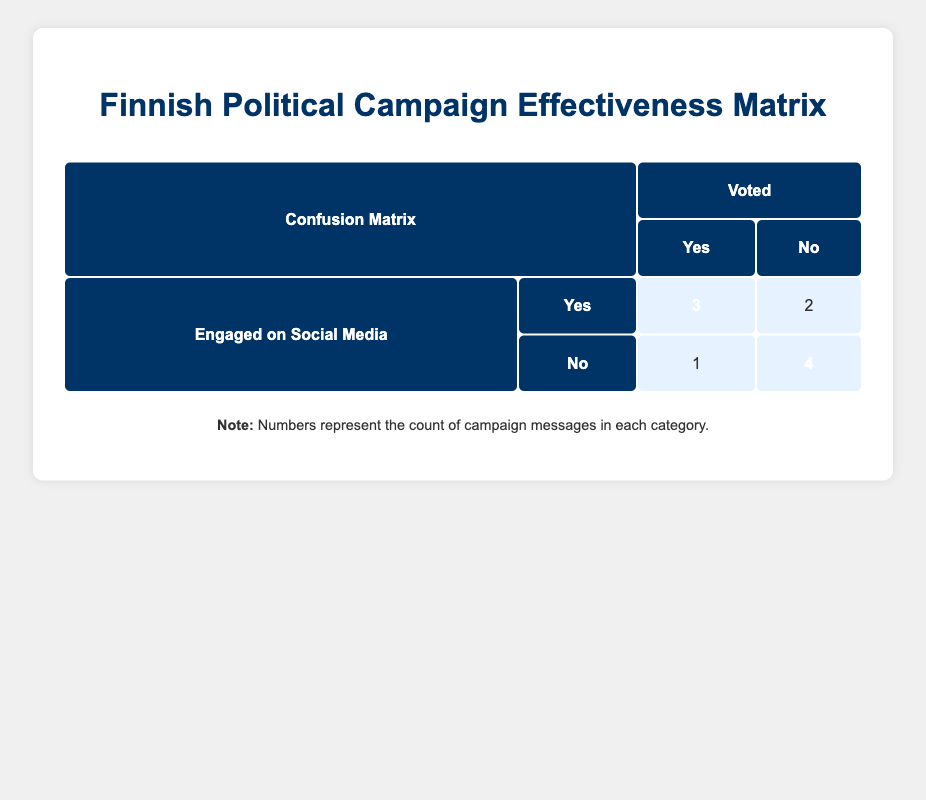What is the total number of campaign messages where voters engaged on social media and voted yes? From the table, we see that there are three instances where voters engaged on social media and voted yes: "Protecting Finnish Nature", "Economic Growth Through Innovation", and "Strengthening Security Policies". Therefore, the total is 3.
Answer: 3 How many campaign messages resulted in no votes but had engagement on social media? There are two campaign messages that were engaged on social media but did not result in votes: "Enhancing Public Healthcare" and "Cultural Preservation Efforts". Thus, the total is 2.
Answer: 2 Are there more campaign messages with non-engagement on social media that resulted in no votes than those that resulted in yes votes? There are four campaign messages that had no engagement on social media and resulted in no votes: "Affordable Housing for Everyone", "Promoting Digital Infrastructure", "Youth Empowerment Programs", and "Boosting Education Funding" (the latter voted yes, which we won't count). In contrast, there is only one campaign message that had no engagement and resulted in a yes vote: "Boosting Education Funding". Hence, the answer is yes, there are more no votes.
Answer: Yes What is the difference between the number of campaign messages that engaged on social media and voted yes versus those that did not engage and voted yes? There are three messages that engaged on social media and voted yes (as identified earlier), while there is only one message that did not engage on social media and voted yes ("Boosting Education Funding"). Therefore, the difference is 3 - 1 = 2.
Answer: 2 Is it true that the majority of campaign messages led to voters engaging on social media while not voting? We have two messages in the category of engaged on social media and voted no ("Enhancing Public Healthcare" and "Cultural Preservation Efforts") alongside four messages in the no engagement and no votes category. Summarizing these, yes: [2 (engaged but did not vote) vs 4 (not engaged and did not vote)]. Hence, it is not true that the majority engaged yet did not vote.
Answer: No What percentage of the campaign messages that received engagement on social media resulted in a vote? Out of the five campaign messages that engaged on social media (3 yes, 2 no), three resulted in yes votes. Therefore, the calculation is (3/5)*100, which equals 60%.
Answer: 60 What is the total number of campaign messages that resulted in a vote of yes? The total number of campaign messages that resulted in a vote of yes is 6: "Protecting Finnish Nature", "Economic Growth Through Innovation", "Strengthening Security Policies", "Increased Support for Elderly Care", and "Boosting Education Funding".
Answer: 6 